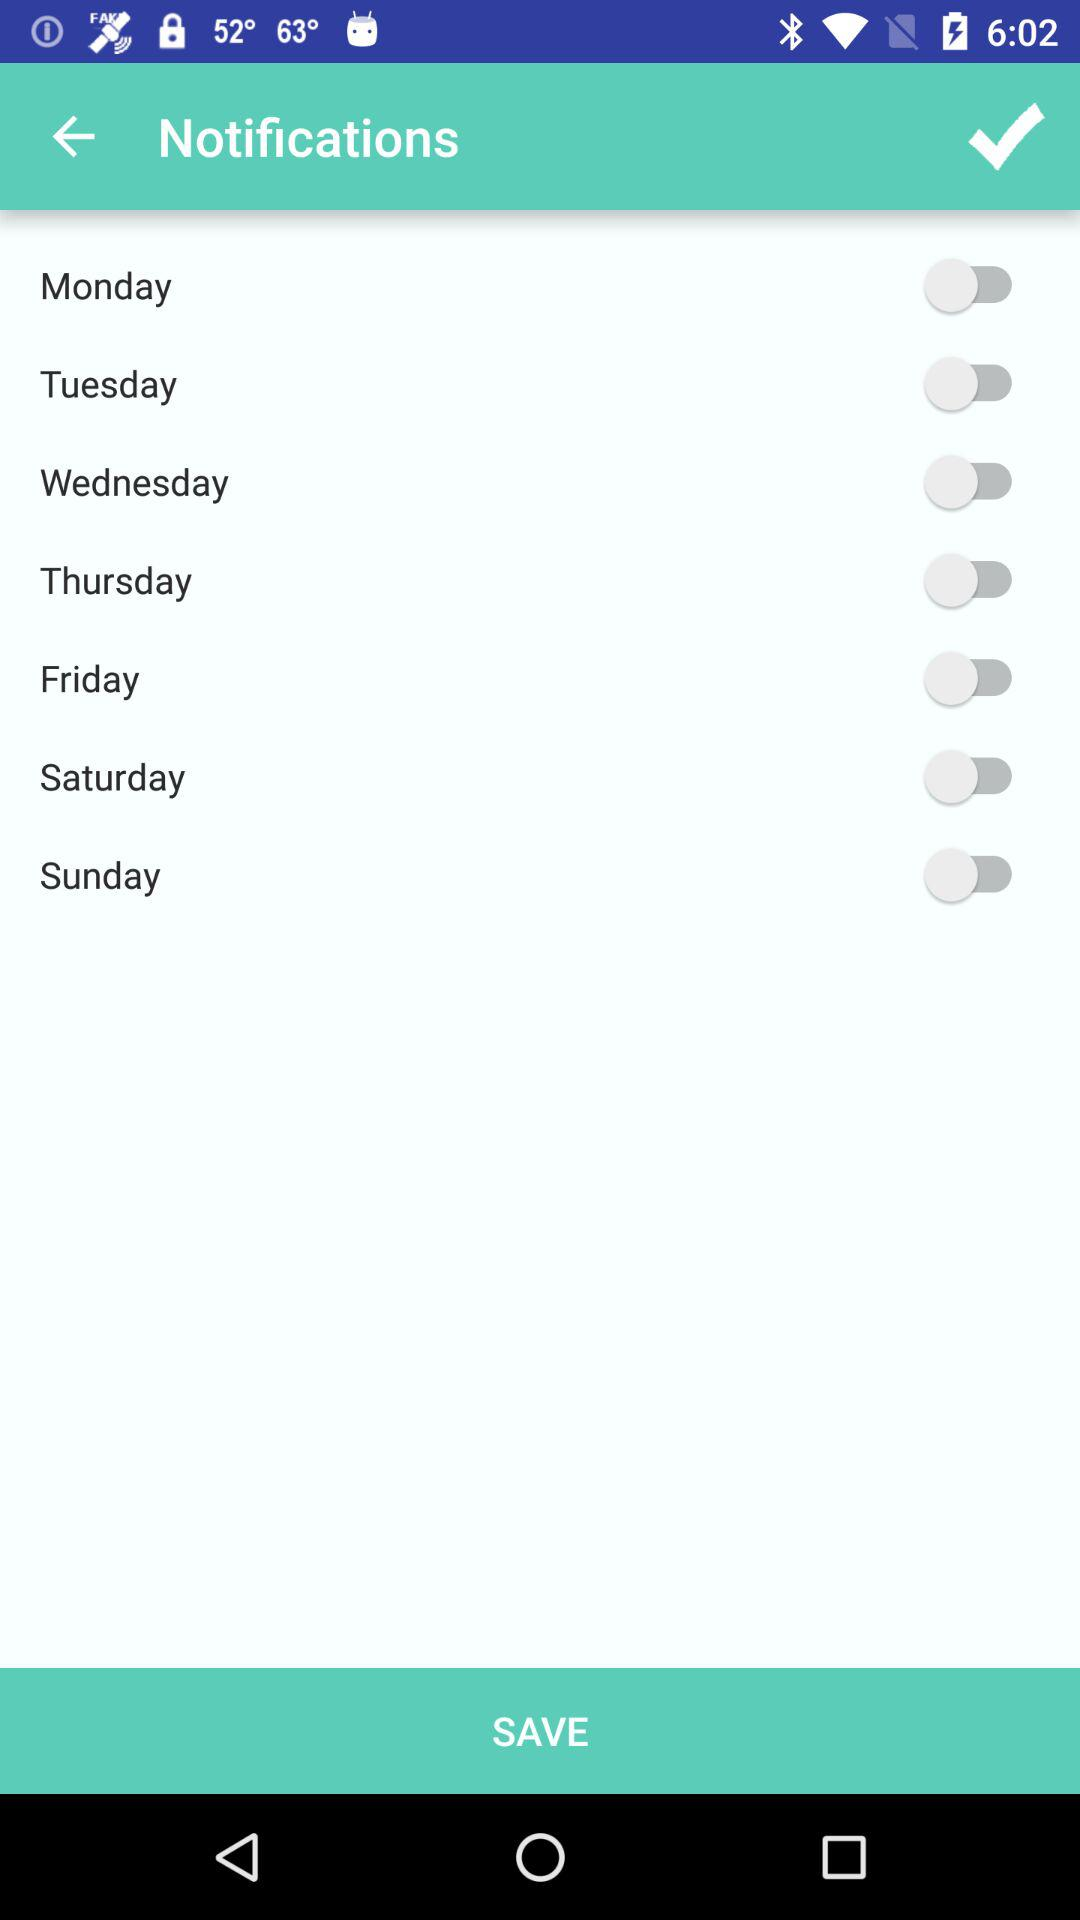What is the status of the holidays?
When the provided information is insufficient, respond with <no answer>. <no answer> 